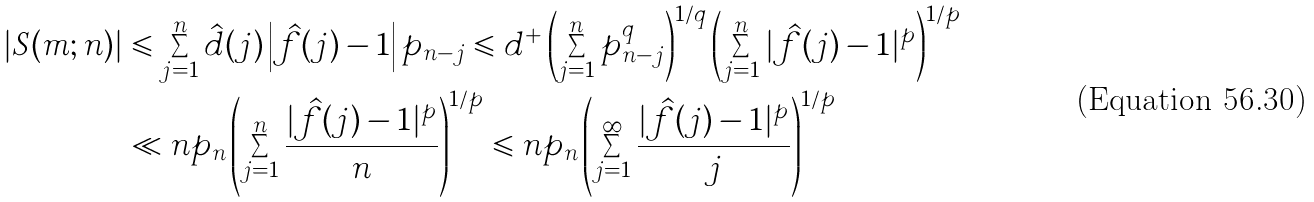Convert formula to latex. <formula><loc_0><loc_0><loc_500><loc_500>| S ( m ; n ) | & \leqslant \sum _ { j = 1 } ^ { n } \hat { d } ( j ) \left | \hat { f } ( j ) - 1 \right | p _ { n - j } \leqslant d ^ { + } \left ( \sum _ { j = 1 } ^ { n } p _ { n - j } ^ { q } \right ) ^ { 1 / q } \left ( \sum _ { j = 1 } ^ { n } | \hat { f } ( j ) - 1 | ^ { p } \right ) ^ { 1 / p } \\ & \ll n p _ { n } \left ( \sum _ { j = 1 } ^ { n } \frac { | \hat { f } ( j ) - 1 | ^ { p } } { n } \right ) ^ { 1 / p } \leqslant n p _ { n } \left ( \sum _ { j = 1 } ^ { \infty } \frac { | \hat { f } ( j ) - 1 | ^ { p } } { j } \right ) ^ { 1 / p }</formula> 